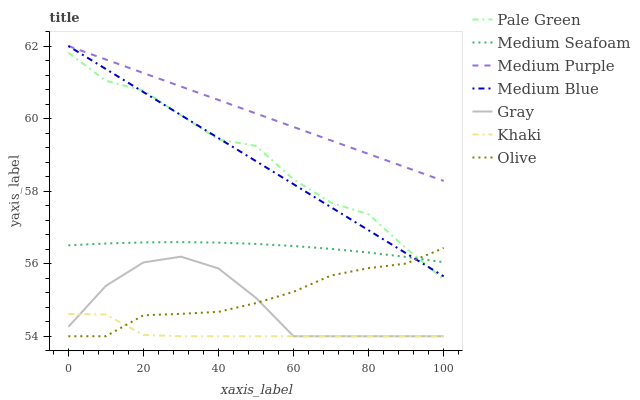Does Khaki have the minimum area under the curve?
Answer yes or no. Yes. Does Medium Purple have the maximum area under the curve?
Answer yes or no. Yes. Does Medium Blue have the minimum area under the curve?
Answer yes or no. No. Does Medium Blue have the maximum area under the curve?
Answer yes or no. No. Is Medium Blue the smoothest?
Answer yes or no. Yes. Is Pale Green the roughest?
Answer yes or no. Yes. Is Khaki the smoothest?
Answer yes or no. No. Is Khaki the roughest?
Answer yes or no. No. Does Medium Blue have the lowest value?
Answer yes or no. No. Does Medium Purple have the highest value?
Answer yes or no. Yes. Does Khaki have the highest value?
Answer yes or no. No. Is Gray less than Medium Seafoam?
Answer yes or no. Yes. Is Medium Blue greater than Khaki?
Answer yes or no. Yes. Does Pale Green intersect Medium Seafoam?
Answer yes or no. Yes. Is Pale Green less than Medium Seafoam?
Answer yes or no. No. Is Pale Green greater than Medium Seafoam?
Answer yes or no. No. Does Gray intersect Medium Seafoam?
Answer yes or no. No. 